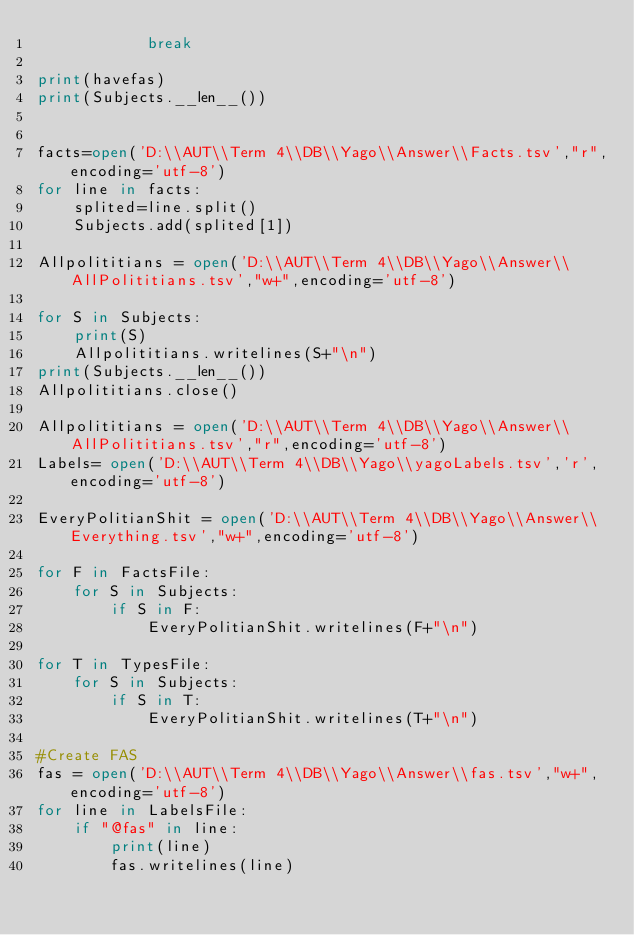<code> <loc_0><loc_0><loc_500><loc_500><_Python_>            break

print(havefas)
print(Subjects.__len__())


facts=open('D:\\AUT\\Term 4\\DB\\Yago\\Answer\\Facts.tsv',"r",encoding='utf-8')
for line in facts:
    splited=line.split()
    Subjects.add(splited[1])

Allpolititians = open('D:\\AUT\\Term 4\\DB\\Yago\\Answer\\AllPolititians.tsv',"w+",encoding='utf-8')

for S in Subjects:
    print(S)
    Allpolititians.writelines(S+"\n")
print(Subjects.__len__())
Allpolititians.close()

Allpolititians = open('D:\\AUT\\Term 4\\DB\\Yago\\Answer\\AllPolititians.tsv',"r",encoding='utf-8')
Labels= open('D:\\AUT\\Term 4\\DB\\Yago\\yagoLabels.tsv','r',encoding='utf-8')

EveryPolitianShit = open('D:\\AUT\\Term 4\\DB\\Yago\\Answer\\Everything.tsv',"w+",encoding='utf-8')

for F in FactsFile:
    for S in Subjects:
        if S in F:
            EveryPolitianShit.writelines(F+"\n")

for T in TypesFile:
    for S in Subjects:
        if S in T:
            EveryPolitianShit.writelines(T+"\n")

#Create FAS
fas = open('D:\\AUT\\Term 4\\DB\\Yago\\Answer\\fas.tsv',"w+",encoding='utf-8')
for line in LabelsFile:
    if "@fas" in line:
        print(line)
        fas.writelines(line)
</code> 